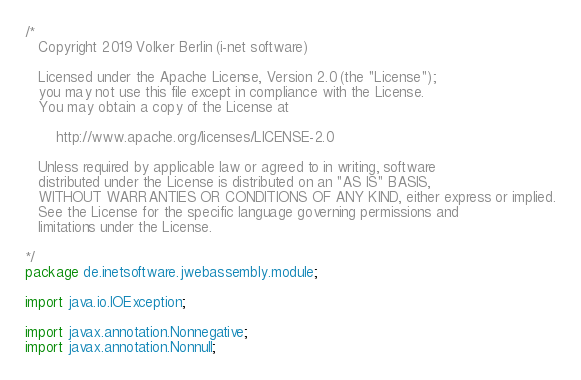<code> <loc_0><loc_0><loc_500><loc_500><_Java_>/*
   Copyright 2019 Volker Berlin (i-net software)

   Licensed under the Apache License, Version 2.0 (the "License");
   you may not use this file except in compliance with the License.
   You may obtain a copy of the License at

       http://www.apache.org/licenses/LICENSE-2.0

   Unless required by applicable law or agreed to in writing, software
   distributed under the License is distributed on an "AS IS" BASIS,
   WITHOUT WARRANTIES OR CONDITIONS OF ANY KIND, either express or implied.
   See the License for the specific language governing permissions and
   limitations under the License.

*/
package de.inetsoftware.jwebassembly.module;

import java.io.IOException;

import javax.annotation.Nonnegative;
import javax.annotation.Nonnull;
</code> 